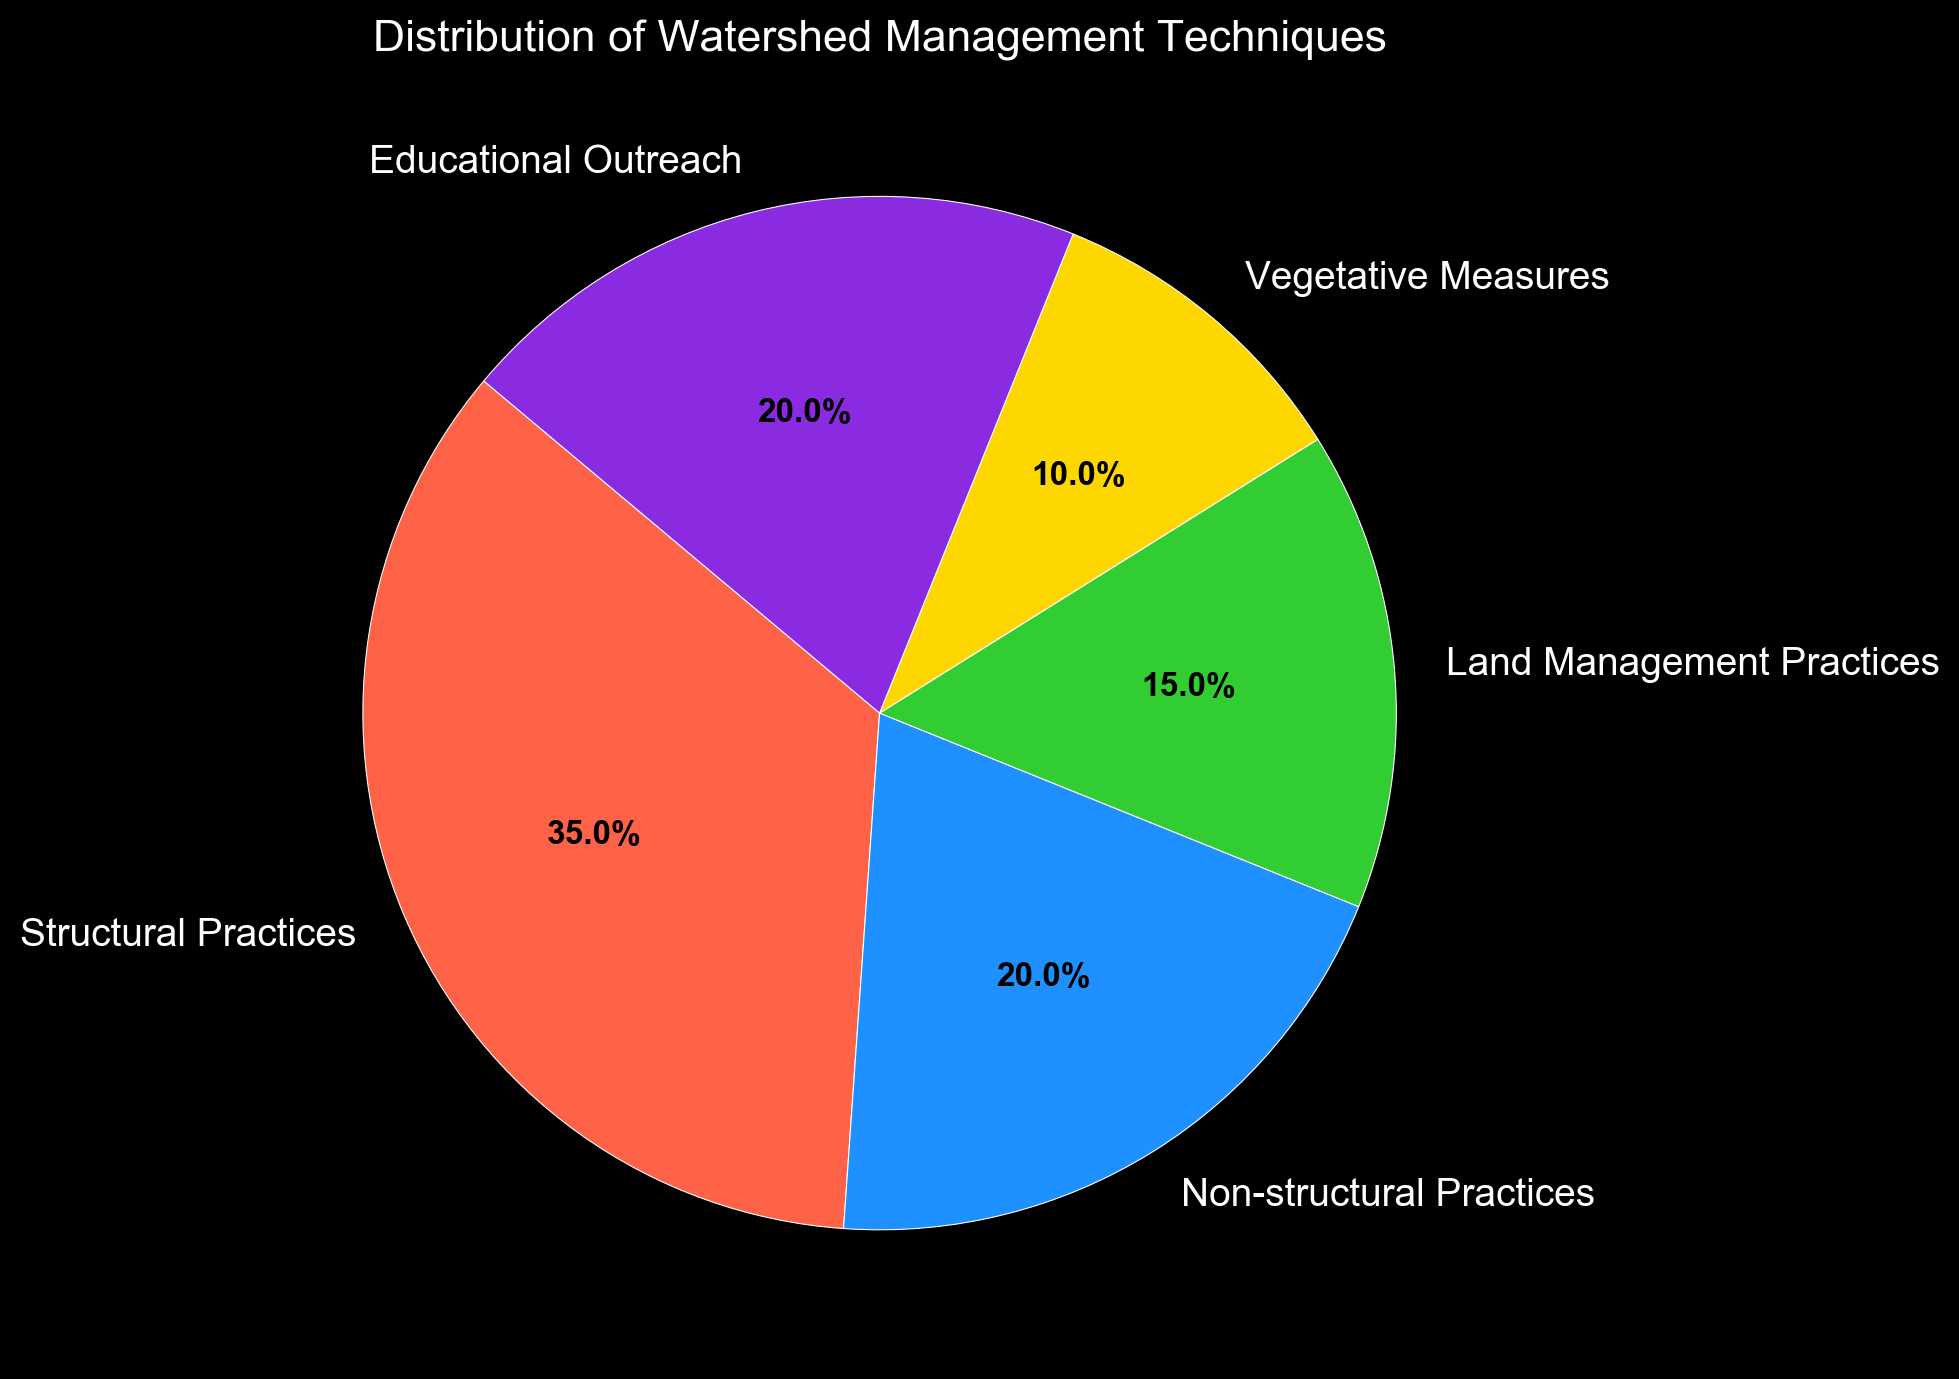What percentage of the total is composed of Structural Practices and Non-structural Practices combined? Structural Practices is 35% and Non-structural Practices is 20%. Adding these together gives 35% + 20% = 55%.
Answer: 55% Which technique has the lowest percentage? The pie chart shows Vegetative Measures with a percentage of 10%, which is the lowest among all the techniques.
Answer: Vegetative Measures How many techniques have a percentage that is 20% or more? According to the pie chart, there are three techniques with percentages 20% or more: Structural Practices (35%), Non-structural Practices (20%), and Educational Outreach (20%).
Answer: 3 Which technique is represented with green color? The green color in the pie chart corresponds to Land Management Practices.
Answer: Land Management Practices How much greater is the percentage of Structural Practices compared to Vegetative Measures? Structural Practices has a percentage of 35%, and Vegetative Measures has a percentage of 10%. The difference is 35% - 10% = 25%.
Answer: 25% If Land Management Practices were to increase by 5%, what would be the new percentage? The current percentage for Land Management Practices is 15%. If it increases by 5%, the new percentage will be 15% + 5% = 20%.
Answer: 20% Which two techniques together make up the largest portion of the pie chart? The percentages for each are: Structural Practices (35%), Non-structural Practices (20%), Land Management Practices (15%), Vegetative Measures (10%), and Educational Outreach (20%). The two largest techniques are Structural Practices and Non-structural Practices, which together add up to 35% + 20% = 55%.
Answer: Structural Practices and Non-structural Practices If you were to create a new technique by combining Land Management Practices and Educational Outreach, what would the combined percentage be? Land Management Practices is 15%, and Educational Outreach is 20%. The combined percentage would be 15% + 20% = 35%.
Answer: 35% What is the second smallest percentage shown on the pie chart? The percentages listed are 35%, 20%, 15%, 10%, and 20%. After 10%, the second smallest percentage is 15%.
Answer: 15% Arrange the techniques in descending order based on their percentages. The percentages are 35%, 20%, 20%, 15%, and 10%. Arranging them in descending order: Structural Practices (35%), Non-structural Practices (20%), Educational Outreach (20%), Land Management Practices (15%), and Vegetative Measures (10%).
Answer: Structural Practices, Non-structural Practices, Educational Outreach, Land Management Practices, Vegetative Measures 